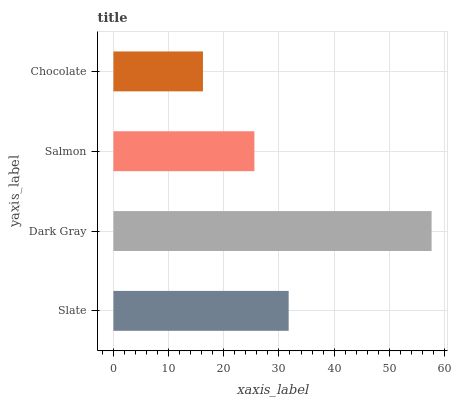Is Chocolate the minimum?
Answer yes or no. Yes. Is Dark Gray the maximum?
Answer yes or no. Yes. Is Salmon the minimum?
Answer yes or no. No. Is Salmon the maximum?
Answer yes or no. No. Is Dark Gray greater than Salmon?
Answer yes or no. Yes. Is Salmon less than Dark Gray?
Answer yes or no. Yes. Is Salmon greater than Dark Gray?
Answer yes or no. No. Is Dark Gray less than Salmon?
Answer yes or no. No. Is Slate the high median?
Answer yes or no. Yes. Is Salmon the low median?
Answer yes or no. Yes. Is Salmon the high median?
Answer yes or no. No. Is Chocolate the low median?
Answer yes or no. No. 